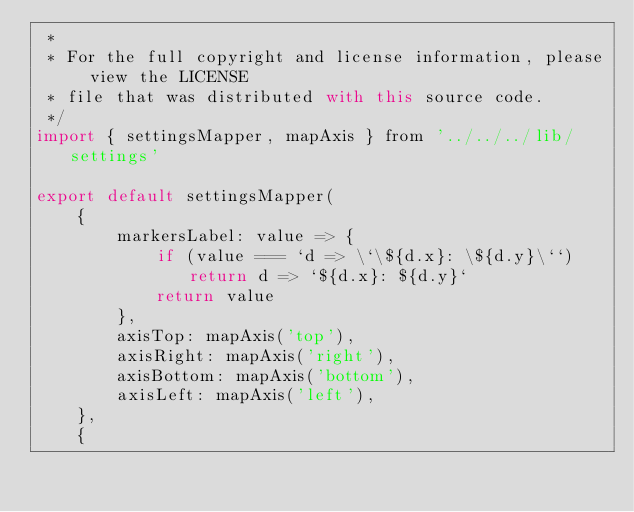<code> <loc_0><loc_0><loc_500><loc_500><_JavaScript_> *
 * For the full copyright and license information, please view the LICENSE
 * file that was distributed with this source code.
 */
import { settingsMapper, mapAxis } from '../../../lib/settings'

export default settingsMapper(
    {
        markersLabel: value => {
            if (value === `d => \`\${d.x}: \${d.y}\``) return d => `${d.x}: ${d.y}`
            return value
        },
        axisTop: mapAxis('top'),
        axisRight: mapAxis('right'),
        axisBottom: mapAxis('bottom'),
        axisLeft: mapAxis('left'),
    },
    {</code> 